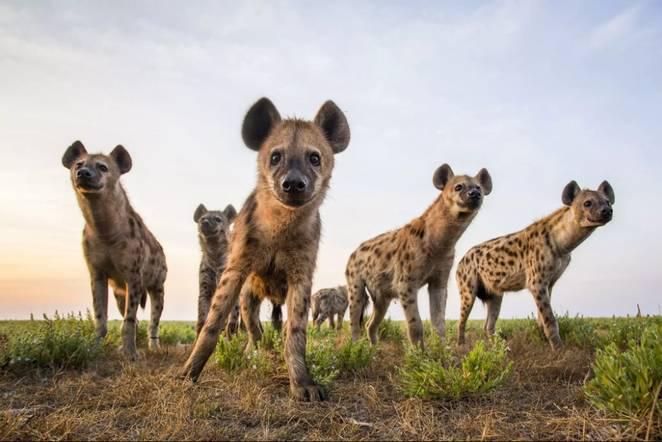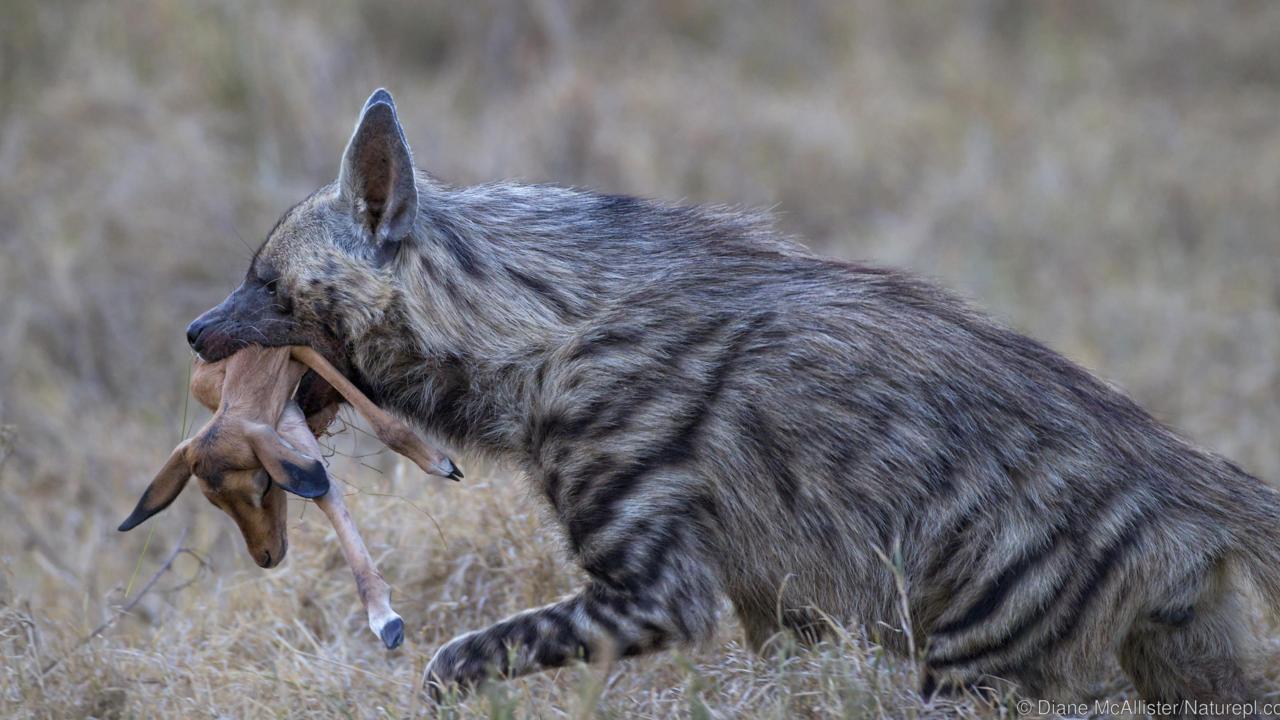The first image is the image on the left, the second image is the image on the right. Assess this claim about the two images: "In at least one image there is a single hyena with an open mouth showing its teeth.". Correct or not? Answer yes or no. No. The first image is the image on the left, the second image is the image on the right. Assess this claim about the two images: "There are only two hyenas.". Correct or not? Answer yes or no. No. 